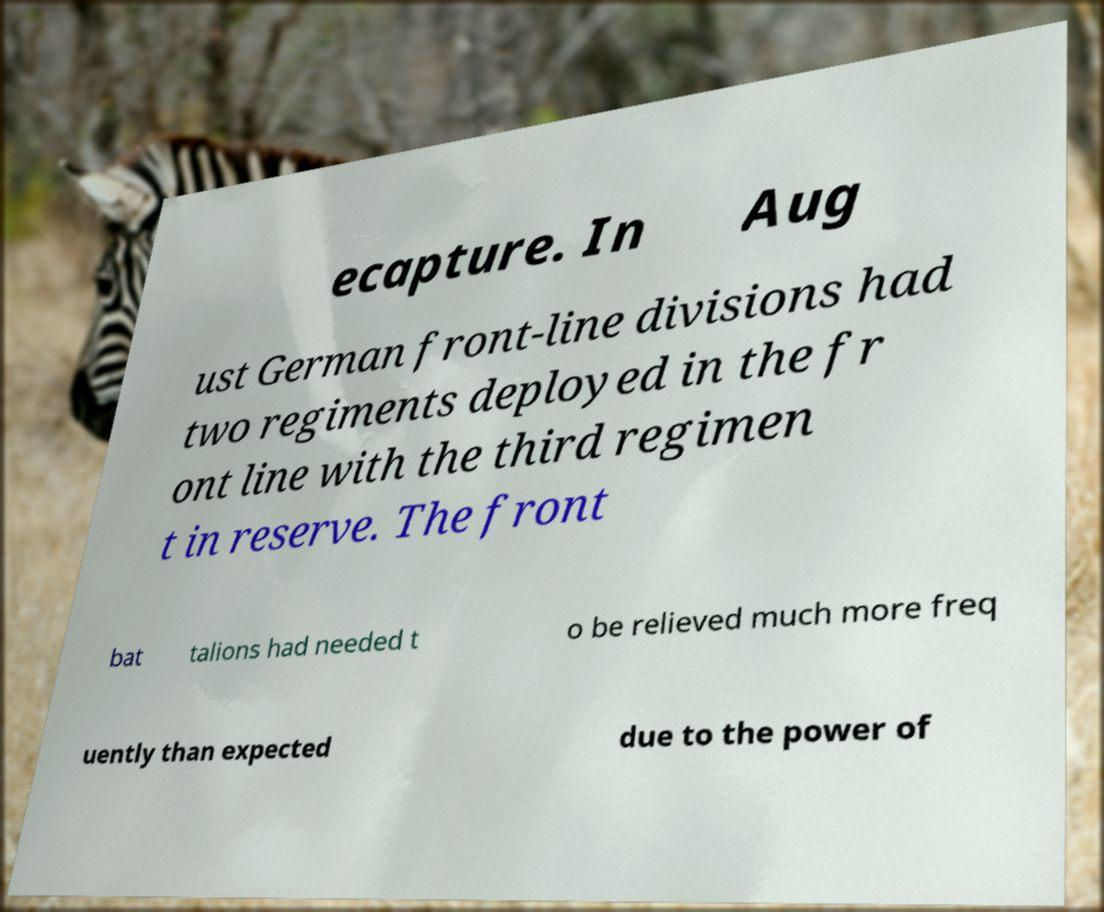Please identify and transcribe the text found in this image. ecapture. In Aug ust German front-line divisions had two regiments deployed in the fr ont line with the third regimen t in reserve. The front bat talions had needed t o be relieved much more freq uently than expected due to the power of 